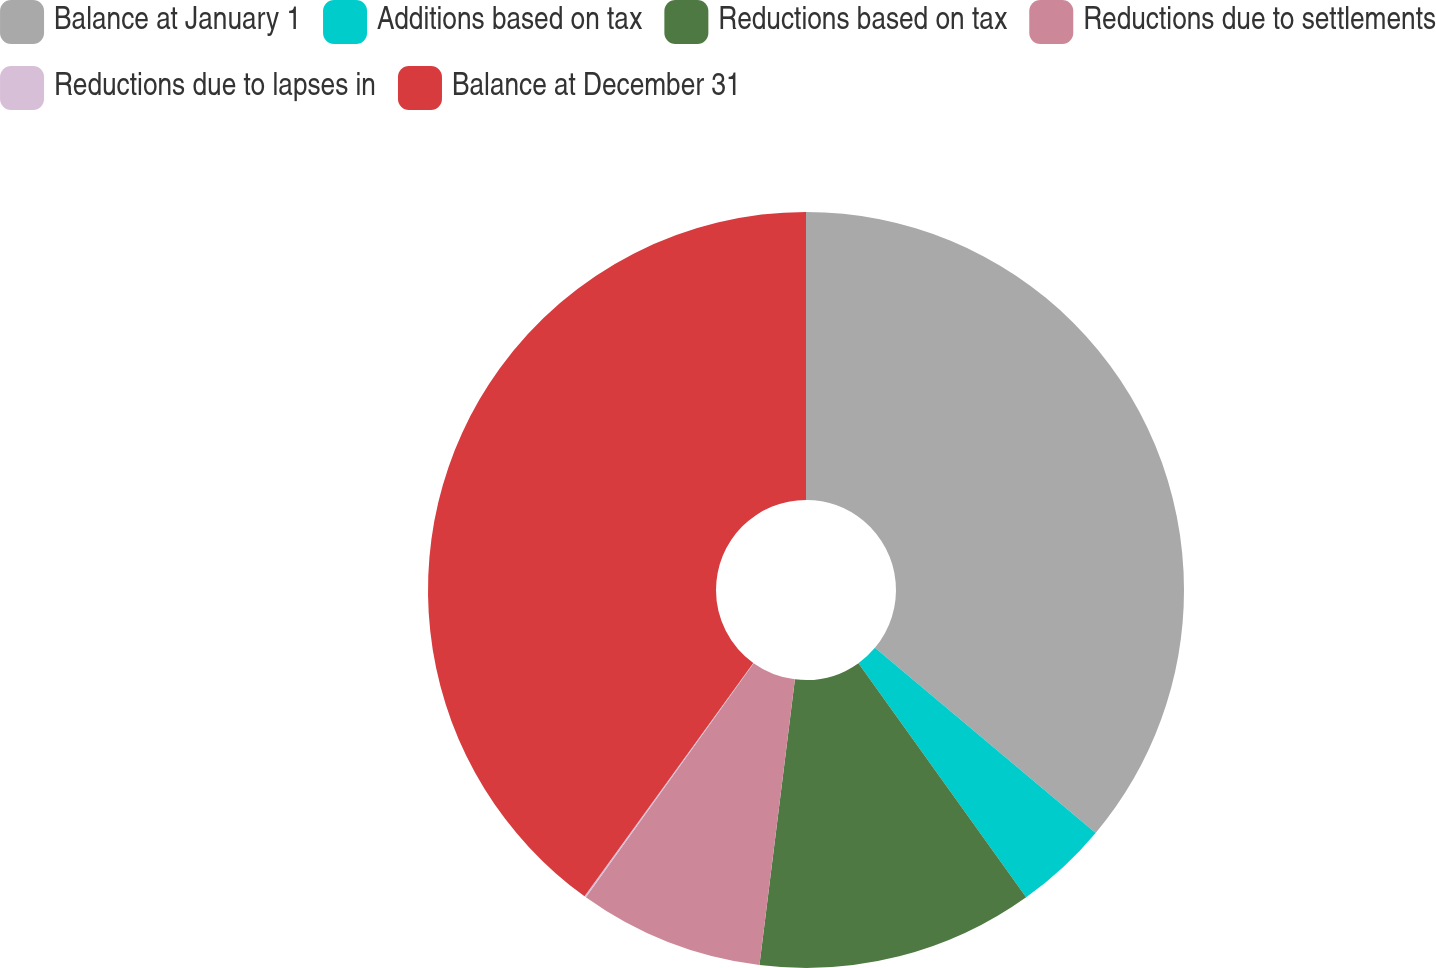Convert chart to OTSL. <chart><loc_0><loc_0><loc_500><loc_500><pie_chart><fcel>Balance at January 1<fcel>Additions based on tax<fcel>Reductions based on tax<fcel>Reductions due to settlements<fcel>Reductions due to lapses in<fcel>Balance at December 31<nl><fcel>36.11%<fcel>4.0%<fcel>11.86%<fcel>7.93%<fcel>0.07%<fcel>40.04%<nl></chart> 